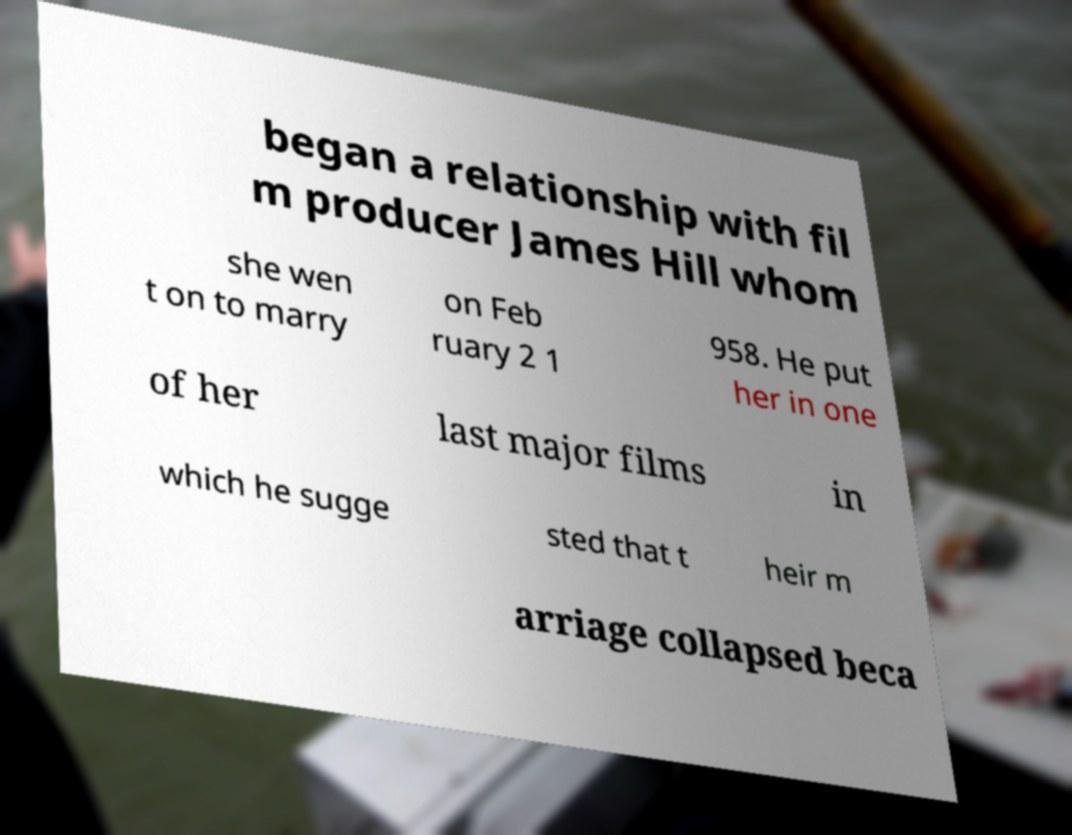Can you accurately transcribe the text from the provided image for me? began a relationship with fil m producer James Hill whom she wen t on to marry on Feb ruary 2 1 958. He put her in one of her last major films in which he sugge sted that t heir m arriage collapsed beca 